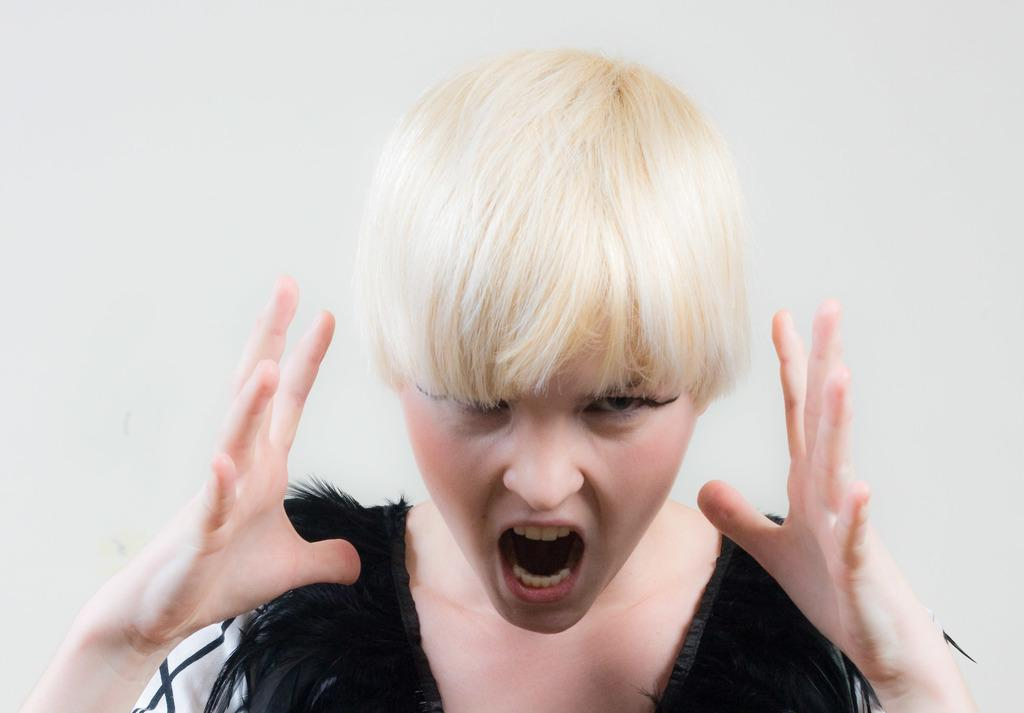Who is the main subject in the image? There is a woman in the image. What is the woman doing in the image? The woman is standing and shouting. What can be seen in the background of the image? There is a wall in the background of the image. What type of request is the woman making in the image? There is no indication in the image that the woman is making a request; she is simply shouting. 